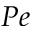<formula> <loc_0><loc_0><loc_500><loc_500>P e</formula> 